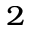Convert formula to latex. <formula><loc_0><loc_0><loc_500><loc_500>^ { 2 }</formula> 